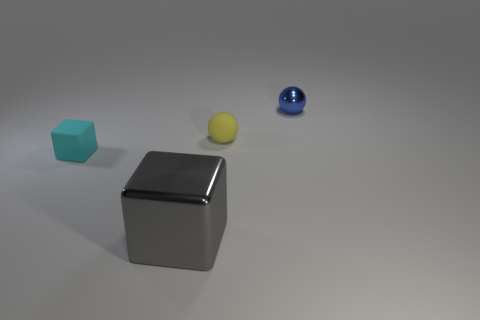Add 4 purple metallic cylinders. How many objects exist? 8 Add 3 tiny cubes. How many tiny cubes are left? 4 Add 2 gray metal spheres. How many gray metal spheres exist? 2 Subtract 1 yellow balls. How many objects are left? 3 Subtract all rubber blocks. Subtract all big metal cubes. How many objects are left? 2 